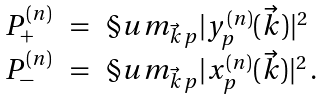<formula> <loc_0><loc_0><loc_500><loc_500>\begin{array} { r c l } P _ { + } ^ { ( n ) } & = & \S u m _ { \vec { k } \, p } | y _ { p } ^ { ( n ) } ( \vec { k } ) | ^ { 2 } \\ P _ { - } ^ { ( n ) } & = & \S u m _ { \vec { k } \, p } | x _ { p } ^ { ( n ) } ( \vec { k } ) | ^ { 2 } \, . \end{array}</formula> 